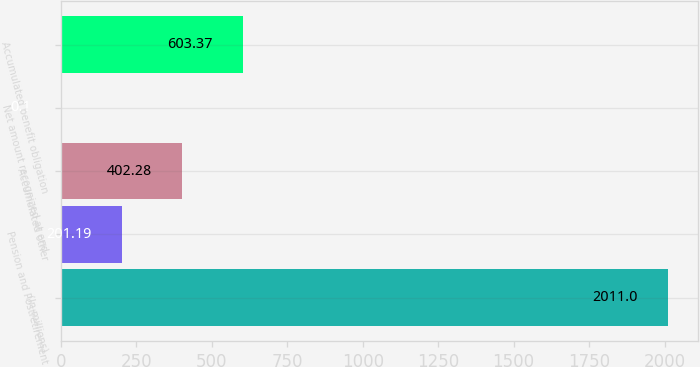Convert chart to OTSL. <chart><loc_0><loc_0><loc_500><loc_500><bar_chart><fcel>(In millions)<fcel>Pension and Postretirement<fcel>Accumulated other<fcel>Net amount recognized at end<fcel>Accumulated benefit obligation<nl><fcel>2011<fcel>201.19<fcel>402.28<fcel>0.1<fcel>603.37<nl></chart> 